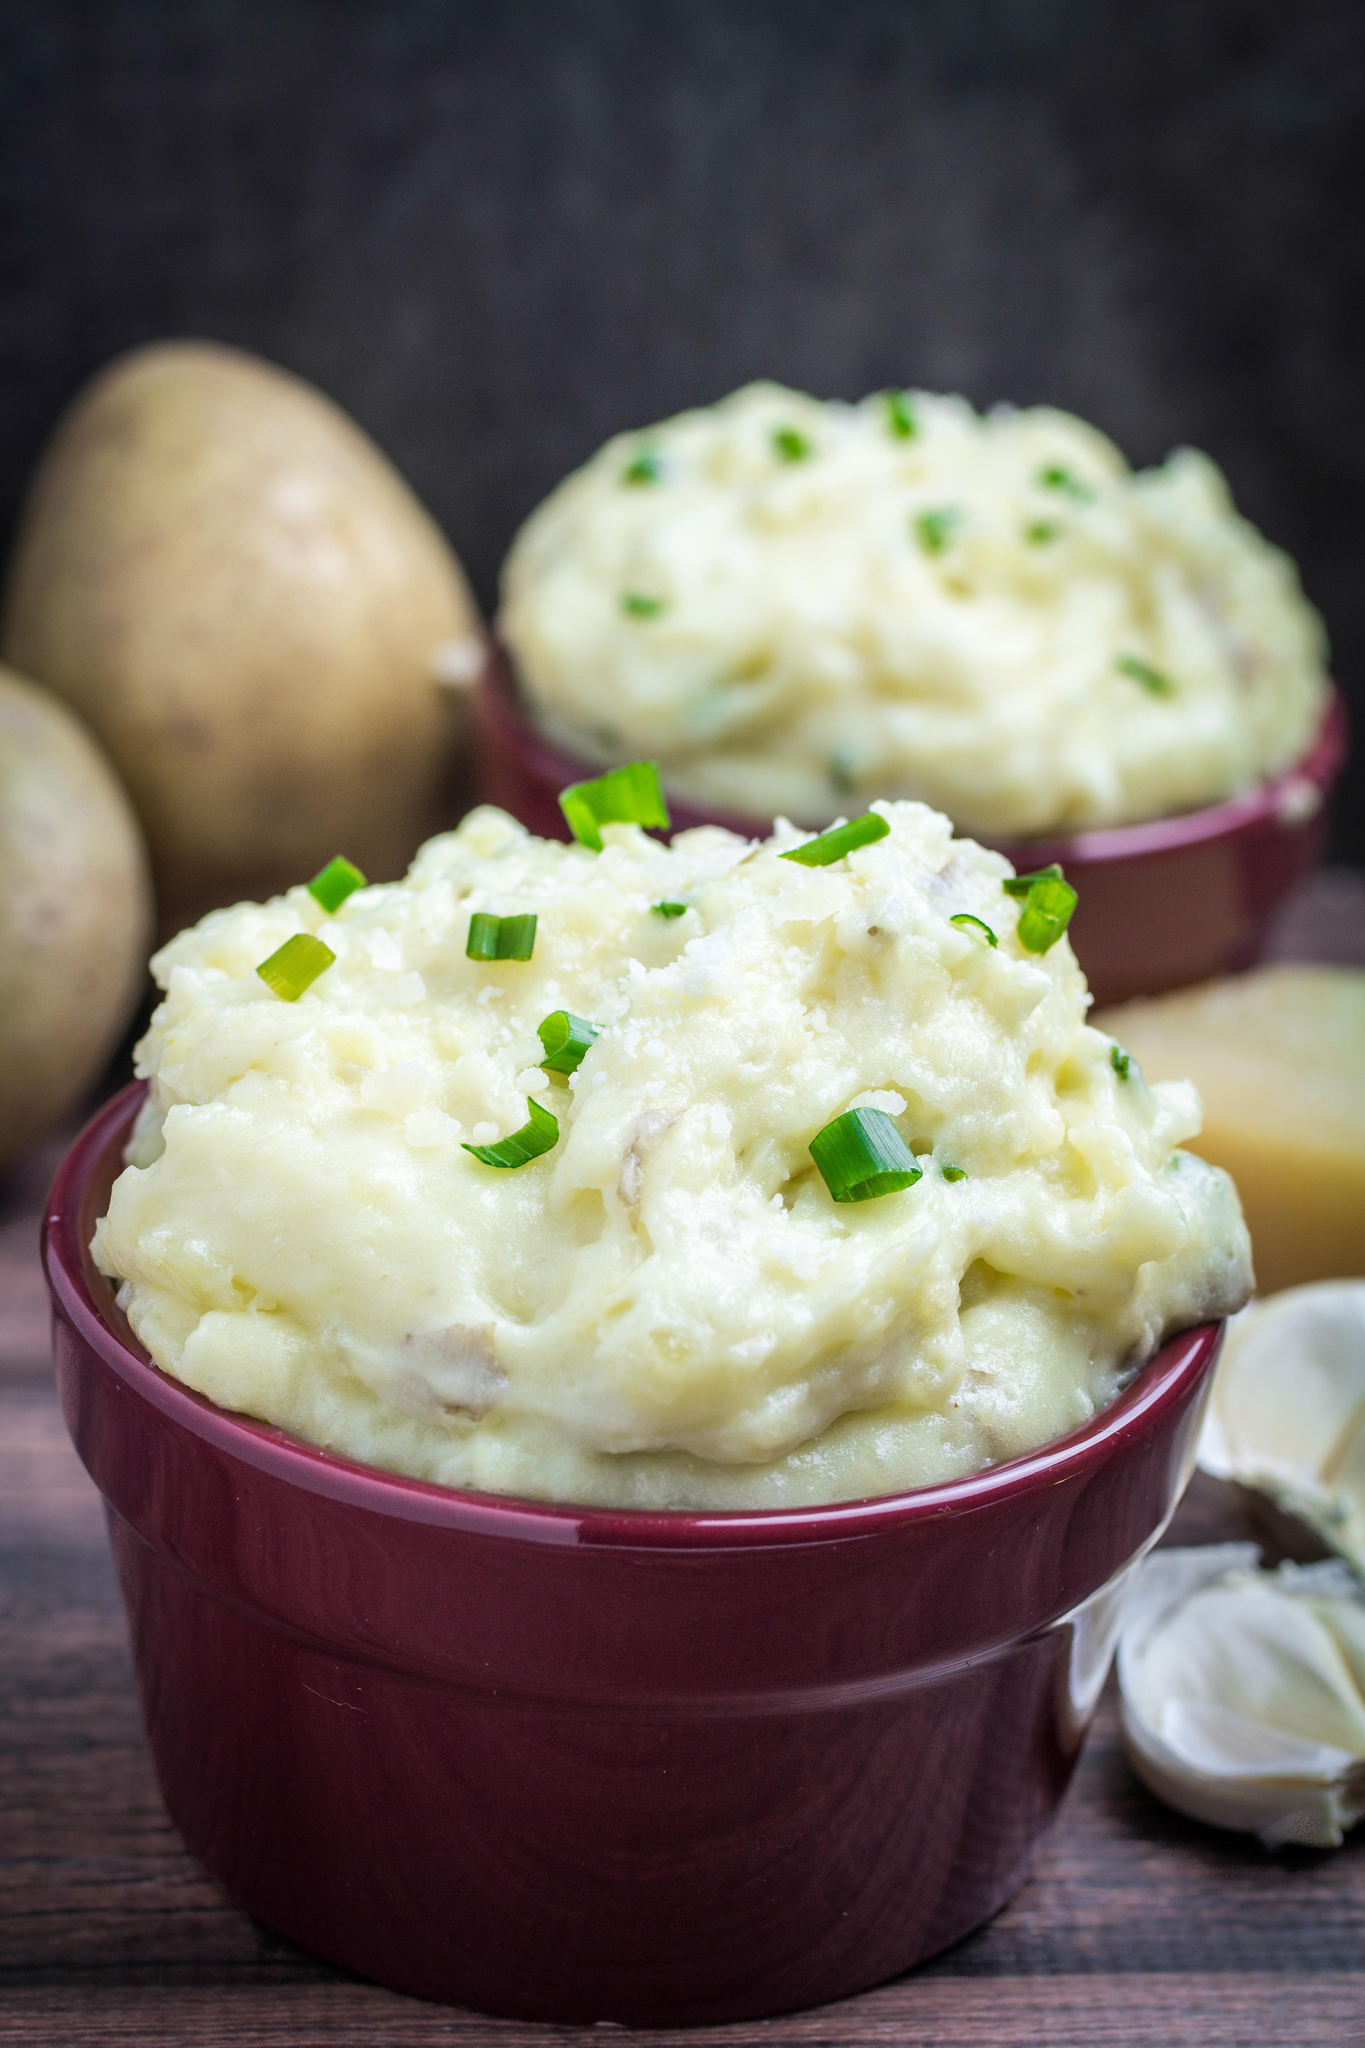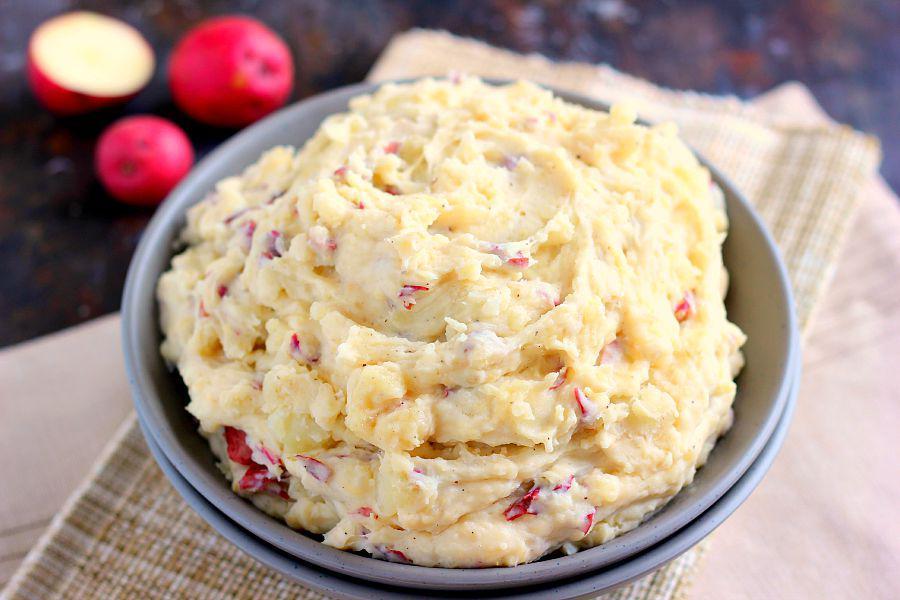The first image is the image on the left, the second image is the image on the right. For the images displayed, is the sentence "One image shows two servings of mashed potatoes in purple bowls." factually correct? Answer yes or no. Yes. The first image is the image on the left, the second image is the image on the right. For the images displayed, is the sentence "There are two bowls of potatoes in one of the images." factually correct? Answer yes or no. Yes. 